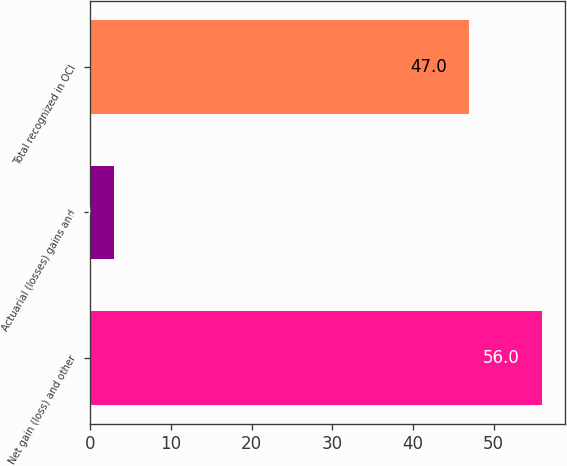Convert chart. <chart><loc_0><loc_0><loc_500><loc_500><bar_chart><fcel>Net gain (loss) and other<fcel>Actuarial (losses) gains and<fcel>Total recognized in OCI<nl><fcel>56<fcel>3<fcel>47<nl></chart> 